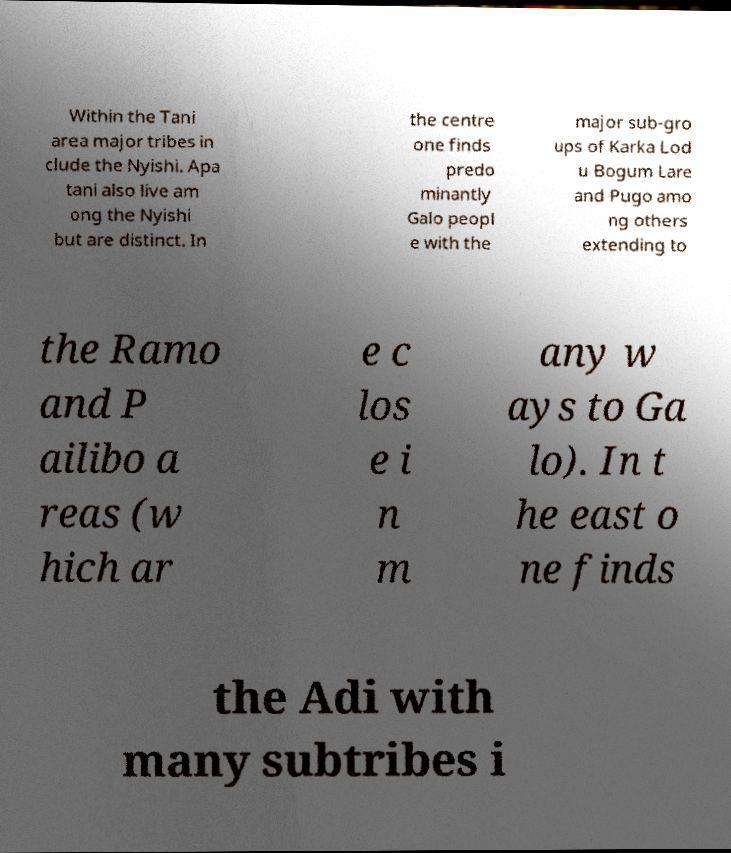Could you assist in decoding the text presented in this image and type it out clearly? Within the Tani area major tribes in clude the Nyishi. Apa tani also live am ong the Nyishi but are distinct. In the centre one finds predo minantly Galo peopl e with the major sub-gro ups of Karka Lod u Bogum Lare and Pugo amo ng others extending to the Ramo and P ailibo a reas (w hich ar e c los e i n m any w ays to Ga lo). In t he east o ne finds the Adi with many subtribes i 